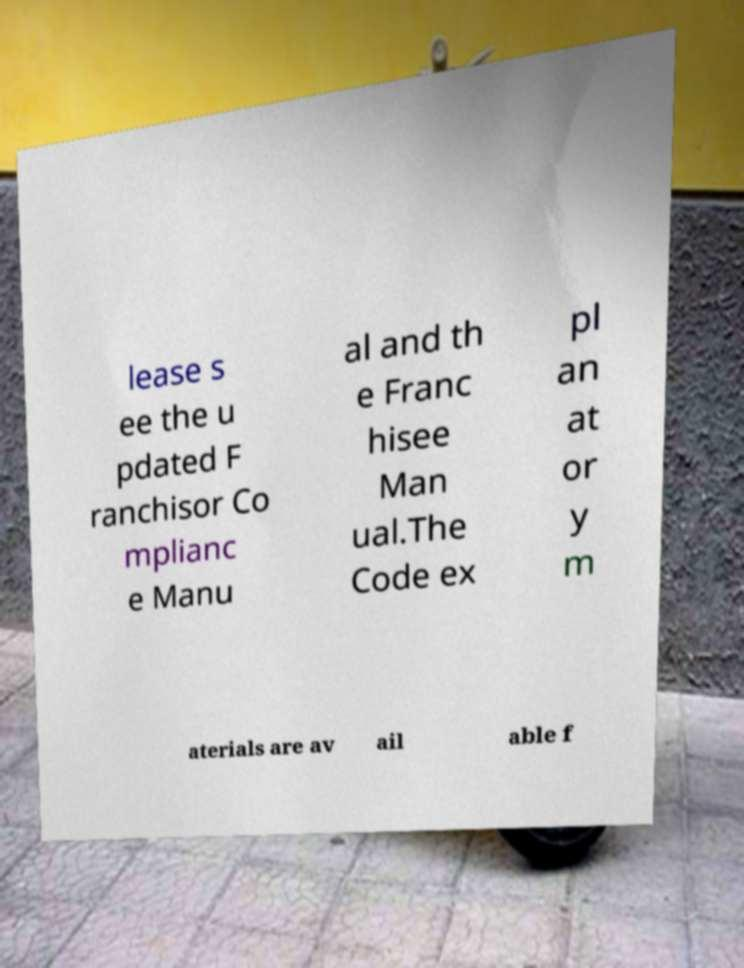There's text embedded in this image that I need extracted. Can you transcribe it verbatim? lease s ee the u pdated F ranchisor Co mplianc e Manu al and th e Franc hisee Man ual.The Code ex pl an at or y m aterials are av ail able f 